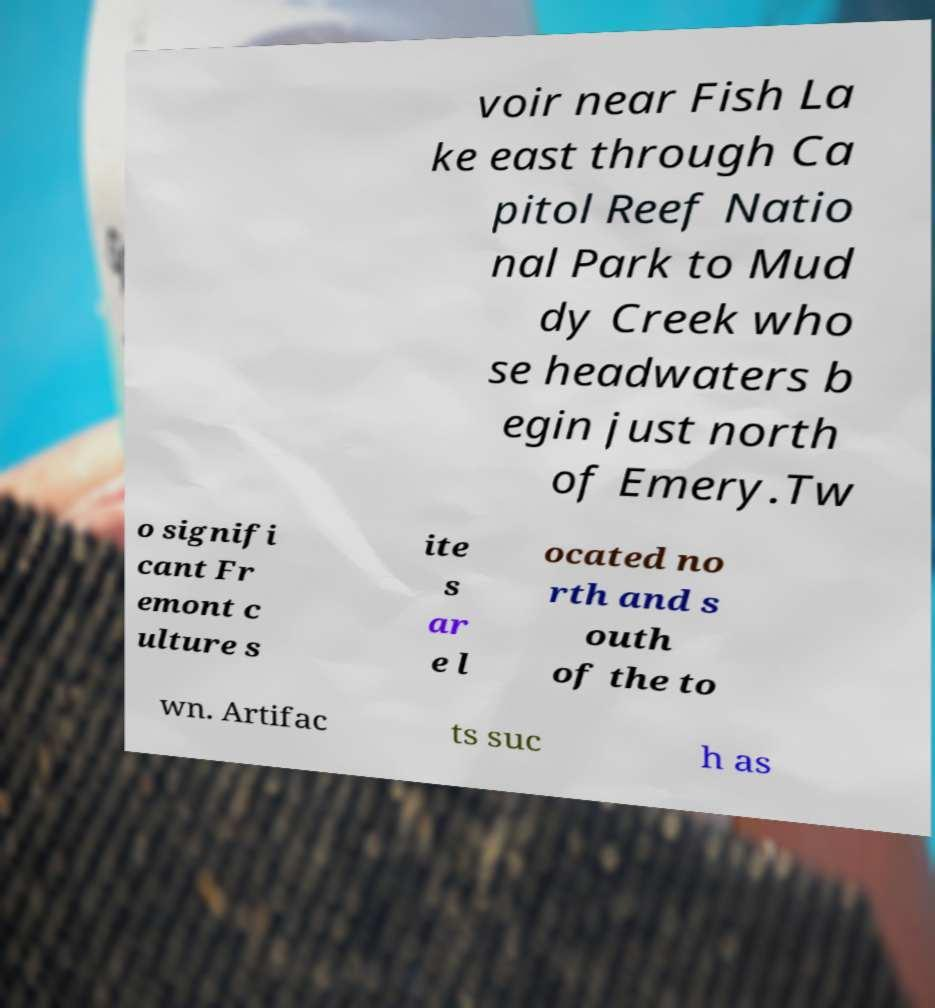Can you read and provide the text displayed in the image?This photo seems to have some interesting text. Can you extract and type it out for me? voir near Fish La ke east through Ca pitol Reef Natio nal Park to Mud dy Creek who se headwaters b egin just north of Emery.Tw o signifi cant Fr emont c ulture s ite s ar e l ocated no rth and s outh of the to wn. Artifac ts suc h as 